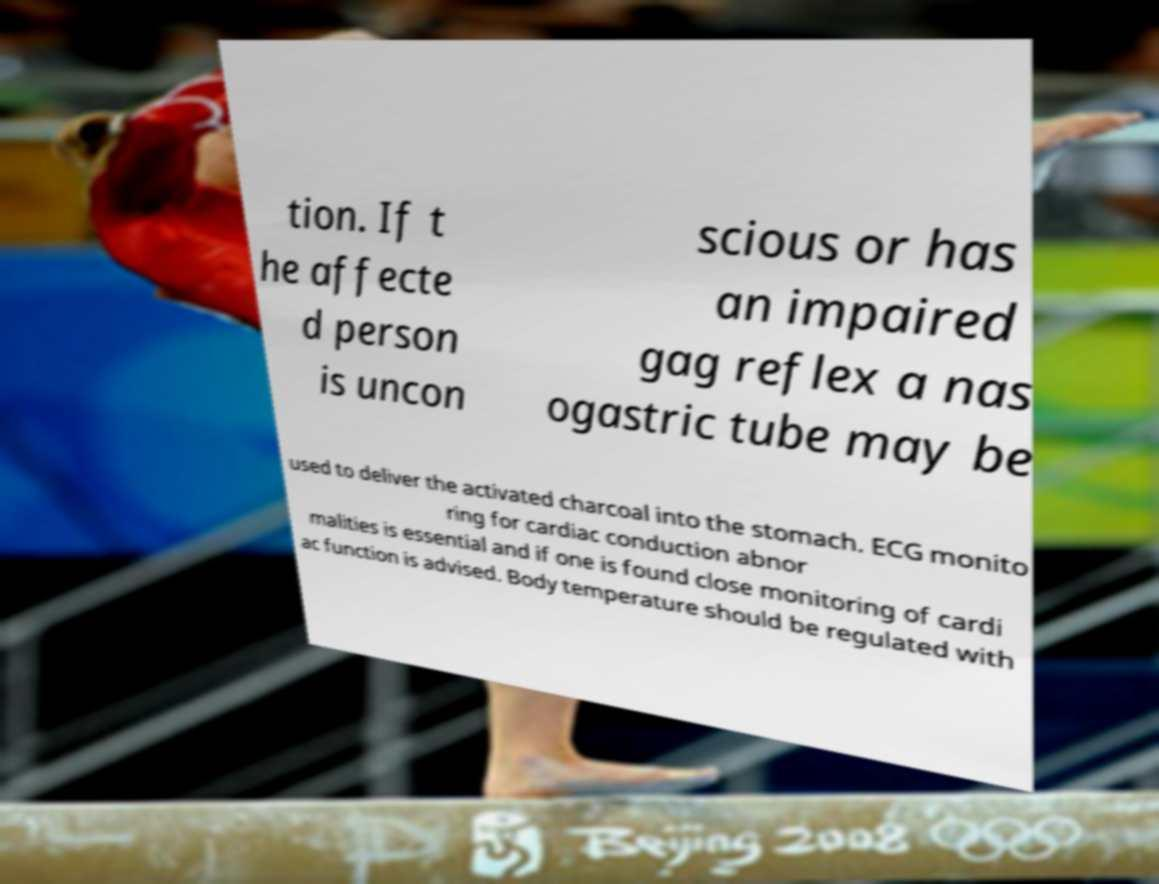For documentation purposes, I need the text within this image transcribed. Could you provide that? tion. If t he affecte d person is uncon scious or has an impaired gag reflex a nas ogastric tube may be used to deliver the activated charcoal into the stomach. ECG monito ring for cardiac conduction abnor malities is essential and if one is found close monitoring of cardi ac function is advised. Body temperature should be regulated with 